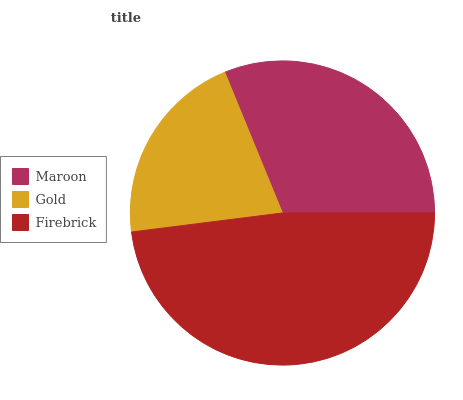Is Gold the minimum?
Answer yes or no. Yes. Is Firebrick the maximum?
Answer yes or no. Yes. Is Firebrick the minimum?
Answer yes or no. No. Is Gold the maximum?
Answer yes or no. No. Is Firebrick greater than Gold?
Answer yes or no. Yes. Is Gold less than Firebrick?
Answer yes or no. Yes. Is Gold greater than Firebrick?
Answer yes or no. No. Is Firebrick less than Gold?
Answer yes or no. No. Is Maroon the high median?
Answer yes or no. Yes. Is Maroon the low median?
Answer yes or no. Yes. Is Gold the high median?
Answer yes or no. No. Is Firebrick the low median?
Answer yes or no. No. 